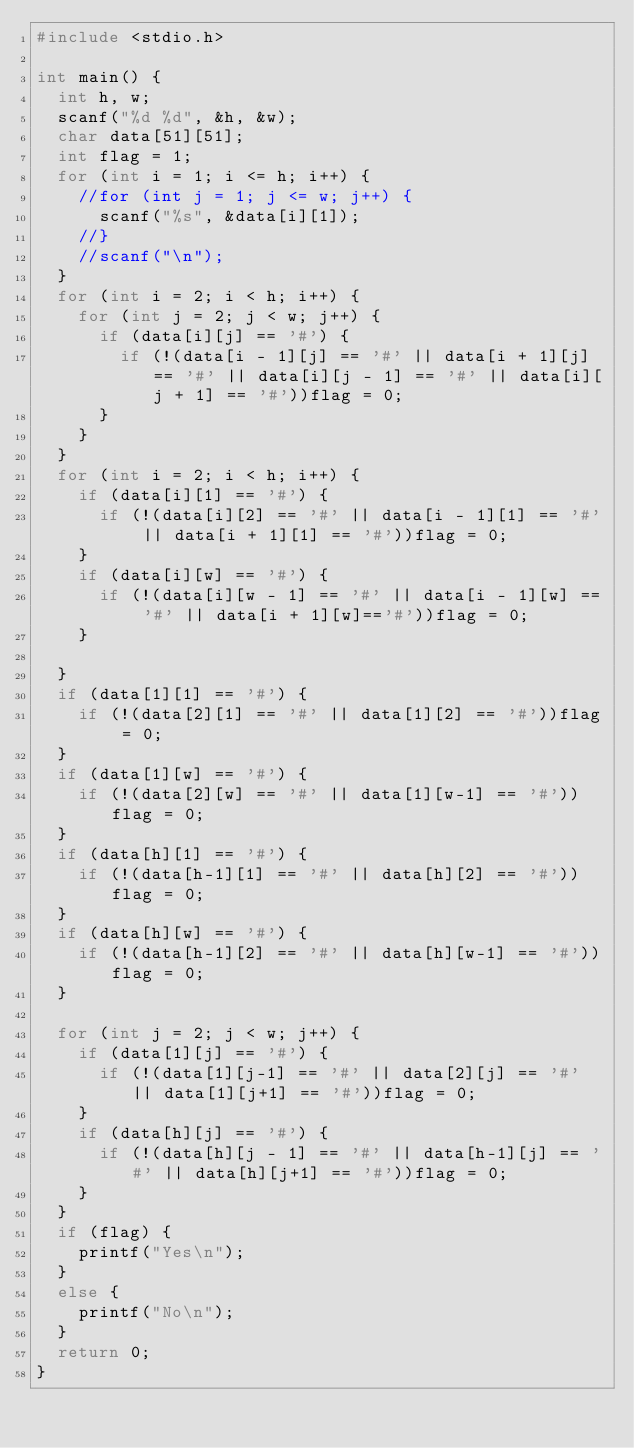<code> <loc_0><loc_0><loc_500><loc_500><_C_>#include <stdio.h>

int main() {
	int h, w;
	scanf("%d %d", &h, &w);
	char data[51][51];
	int flag = 1;
	for (int i = 1; i <= h; i++) {
		//for (int j = 1; j <= w; j++) {
			scanf("%s", &data[i][1]);
		//}
		//scanf("\n");
	}
	for (int i = 2; i < h; i++) {
		for (int j = 2; j < w; j++) {
			if (data[i][j] == '#') {
				if (!(data[i - 1][j] == '#' || data[i + 1][j] == '#' || data[i][j - 1] == '#' || data[i][j + 1] == '#'))flag = 0;
			}
		}
	}
	for (int i = 2; i < h; i++) {
		if (data[i][1] == '#') {
			if (!(data[i][2] == '#' || data[i - 1][1] == '#' || data[i + 1][1] == '#'))flag = 0;
		}
		if (data[i][w] == '#') {
			if (!(data[i][w - 1] == '#' || data[i - 1][w] == '#' || data[i + 1][w]=='#'))flag = 0;
		}

	}
	if (data[1][1] == '#') {
		if (!(data[2][1] == '#' || data[1][2] == '#'))flag = 0;
	}
	if (data[1][w] == '#') {
		if (!(data[2][w] == '#' || data[1][w-1] == '#'))flag = 0;
	}
	if (data[h][1] == '#') {
		if (!(data[h-1][1] == '#' || data[h][2] == '#'))flag = 0;
	}
	if (data[h][w] == '#') {
		if (!(data[h-1][2] == '#' || data[h][w-1] == '#'))flag = 0;
	}
	
	for (int j = 2; j < w; j++) {
		if (data[1][j] == '#') {
			if (!(data[1][j-1] == '#' || data[2][j] == '#' || data[1][j+1] == '#'))flag = 0;
		}
		if (data[h][j] == '#') {
			if (!(data[h][j - 1] == '#' || data[h-1][j] == '#' || data[h][j+1] == '#'))flag = 0;
		}
	}
	if (flag) {
		printf("Yes\n");
	}
	else {
		printf("No\n");
	}
	return 0;
}</code> 